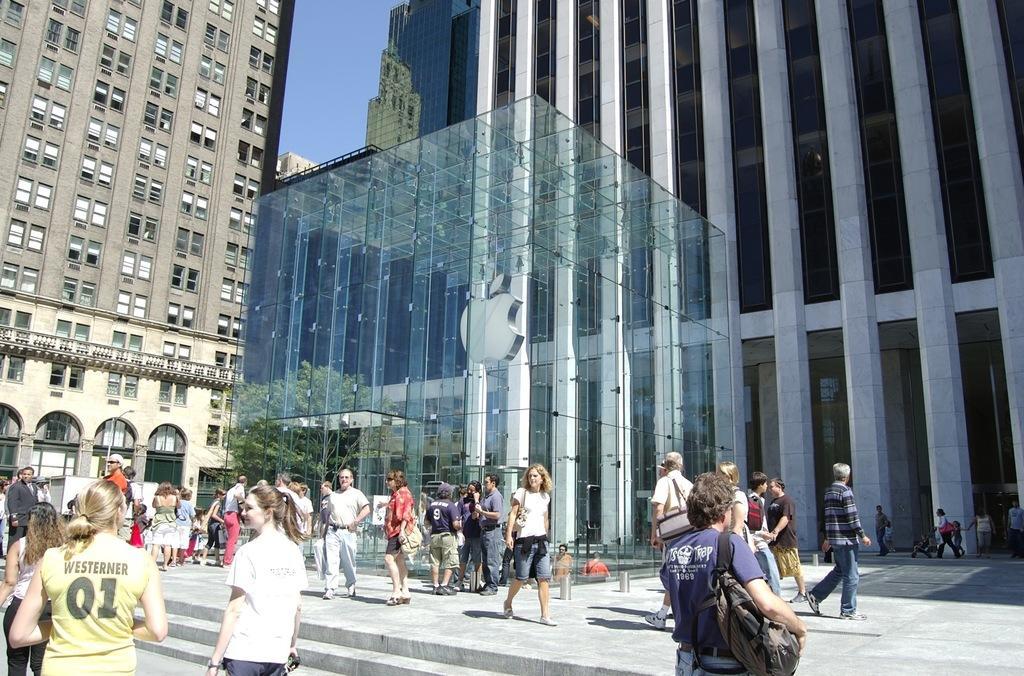In one or two sentences, can you explain what this image depicts? In this image we can see there are many people at the bottom and in the middle we can see a logo of an apple, at the back I can see some buildings. 